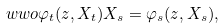<formula> <loc_0><loc_0><loc_500><loc_500>\ w w o { \varphi _ { t } ( z , X _ { t } ) } { X _ { s } } = \varphi _ { s } ( z , X _ { s } ) ,</formula> 